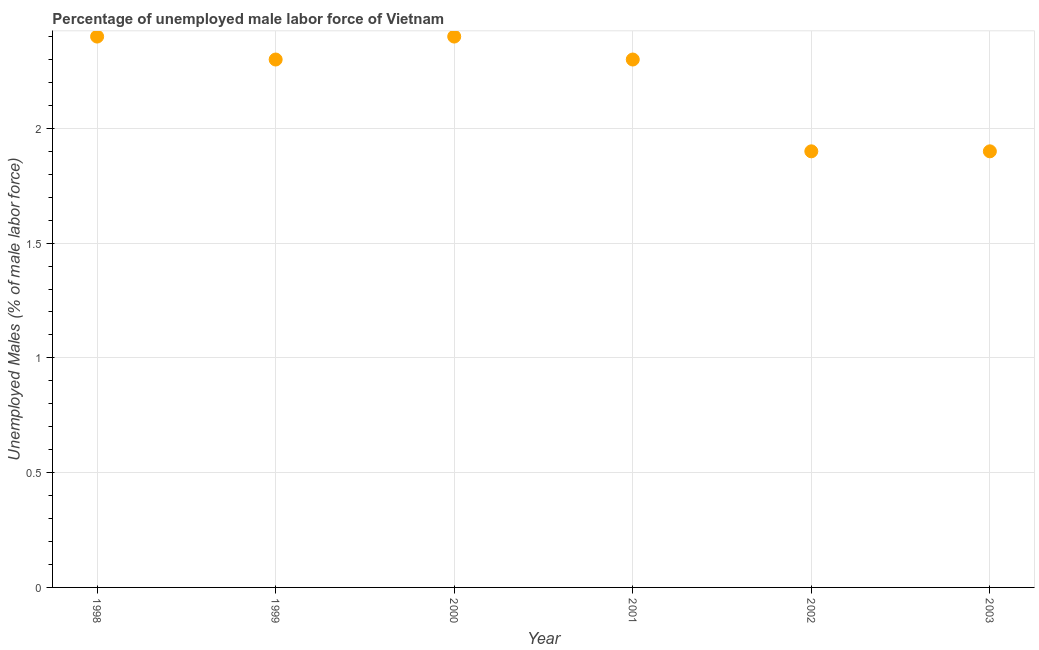What is the total unemployed male labour force in 2000?
Keep it short and to the point. 2.4. Across all years, what is the maximum total unemployed male labour force?
Provide a succinct answer. 2.4. Across all years, what is the minimum total unemployed male labour force?
Make the answer very short. 1.9. In which year was the total unemployed male labour force maximum?
Your answer should be compact. 1998. In which year was the total unemployed male labour force minimum?
Provide a succinct answer. 2002. What is the sum of the total unemployed male labour force?
Provide a short and direct response. 13.2. What is the difference between the total unemployed male labour force in 1998 and 2003?
Provide a succinct answer. 0.5. What is the average total unemployed male labour force per year?
Your answer should be very brief. 2.2. What is the median total unemployed male labour force?
Your answer should be very brief. 2.3. What is the ratio of the total unemployed male labour force in 2001 to that in 2002?
Ensure brevity in your answer.  1.21. What is the difference between the highest and the second highest total unemployed male labour force?
Provide a short and direct response. 0. What is the difference between the highest and the lowest total unemployed male labour force?
Your answer should be compact. 0.5. In how many years, is the total unemployed male labour force greater than the average total unemployed male labour force taken over all years?
Give a very brief answer. 4. How many dotlines are there?
Make the answer very short. 1. Are the values on the major ticks of Y-axis written in scientific E-notation?
Give a very brief answer. No. Does the graph contain any zero values?
Make the answer very short. No. What is the title of the graph?
Keep it short and to the point. Percentage of unemployed male labor force of Vietnam. What is the label or title of the X-axis?
Your response must be concise. Year. What is the label or title of the Y-axis?
Provide a succinct answer. Unemployed Males (% of male labor force). What is the Unemployed Males (% of male labor force) in 1998?
Ensure brevity in your answer.  2.4. What is the Unemployed Males (% of male labor force) in 1999?
Provide a short and direct response. 2.3. What is the Unemployed Males (% of male labor force) in 2000?
Provide a short and direct response. 2.4. What is the Unemployed Males (% of male labor force) in 2001?
Your response must be concise. 2.3. What is the Unemployed Males (% of male labor force) in 2002?
Your answer should be very brief. 1.9. What is the Unemployed Males (% of male labor force) in 2003?
Offer a terse response. 1.9. What is the difference between the Unemployed Males (% of male labor force) in 1998 and 1999?
Ensure brevity in your answer.  0.1. What is the difference between the Unemployed Males (% of male labor force) in 1998 and 2003?
Keep it short and to the point. 0.5. What is the difference between the Unemployed Males (% of male labor force) in 1999 and 2002?
Provide a succinct answer. 0.4. What is the difference between the Unemployed Males (% of male labor force) in 2000 and 2003?
Provide a short and direct response. 0.5. What is the difference between the Unemployed Males (% of male labor force) in 2002 and 2003?
Provide a succinct answer. 0. What is the ratio of the Unemployed Males (% of male labor force) in 1998 to that in 1999?
Keep it short and to the point. 1.04. What is the ratio of the Unemployed Males (% of male labor force) in 1998 to that in 2000?
Your answer should be very brief. 1. What is the ratio of the Unemployed Males (% of male labor force) in 1998 to that in 2001?
Offer a terse response. 1.04. What is the ratio of the Unemployed Males (% of male labor force) in 1998 to that in 2002?
Your answer should be very brief. 1.26. What is the ratio of the Unemployed Males (% of male labor force) in 1998 to that in 2003?
Your answer should be compact. 1.26. What is the ratio of the Unemployed Males (% of male labor force) in 1999 to that in 2000?
Offer a very short reply. 0.96. What is the ratio of the Unemployed Males (% of male labor force) in 1999 to that in 2002?
Provide a succinct answer. 1.21. What is the ratio of the Unemployed Males (% of male labor force) in 1999 to that in 2003?
Provide a succinct answer. 1.21. What is the ratio of the Unemployed Males (% of male labor force) in 2000 to that in 2001?
Provide a succinct answer. 1.04. What is the ratio of the Unemployed Males (% of male labor force) in 2000 to that in 2002?
Provide a short and direct response. 1.26. What is the ratio of the Unemployed Males (% of male labor force) in 2000 to that in 2003?
Offer a terse response. 1.26. What is the ratio of the Unemployed Males (% of male labor force) in 2001 to that in 2002?
Keep it short and to the point. 1.21. What is the ratio of the Unemployed Males (% of male labor force) in 2001 to that in 2003?
Offer a terse response. 1.21. What is the ratio of the Unemployed Males (% of male labor force) in 2002 to that in 2003?
Your response must be concise. 1. 